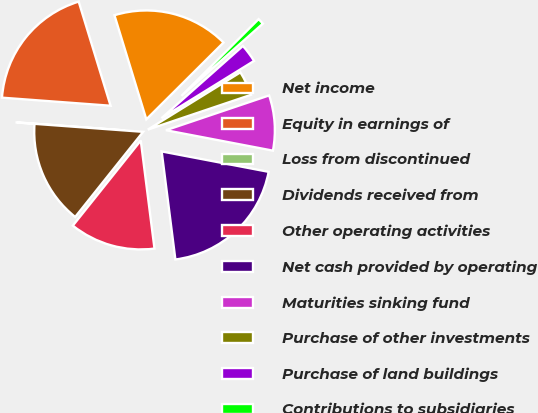Convert chart. <chart><loc_0><loc_0><loc_500><loc_500><pie_chart><fcel>Net income<fcel>Equity in earnings of<fcel>Loss from discontinued<fcel>Dividends received from<fcel>Other operating activities<fcel>Net cash provided by operating<fcel>Maturities sinking fund<fcel>Purchase of other investments<fcel>Purchase of land buildings<fcel>Contributions to subsidiaries<nl><fcel>17.27%<fcel>19.09%<fcel>0.01%<fcel>15.45%<fcel>12.73%<fcel>19.99%<fcel>8.18%<fcel>3.64%<fcel>2.73%<fcel>0.91%<nl></chart> 